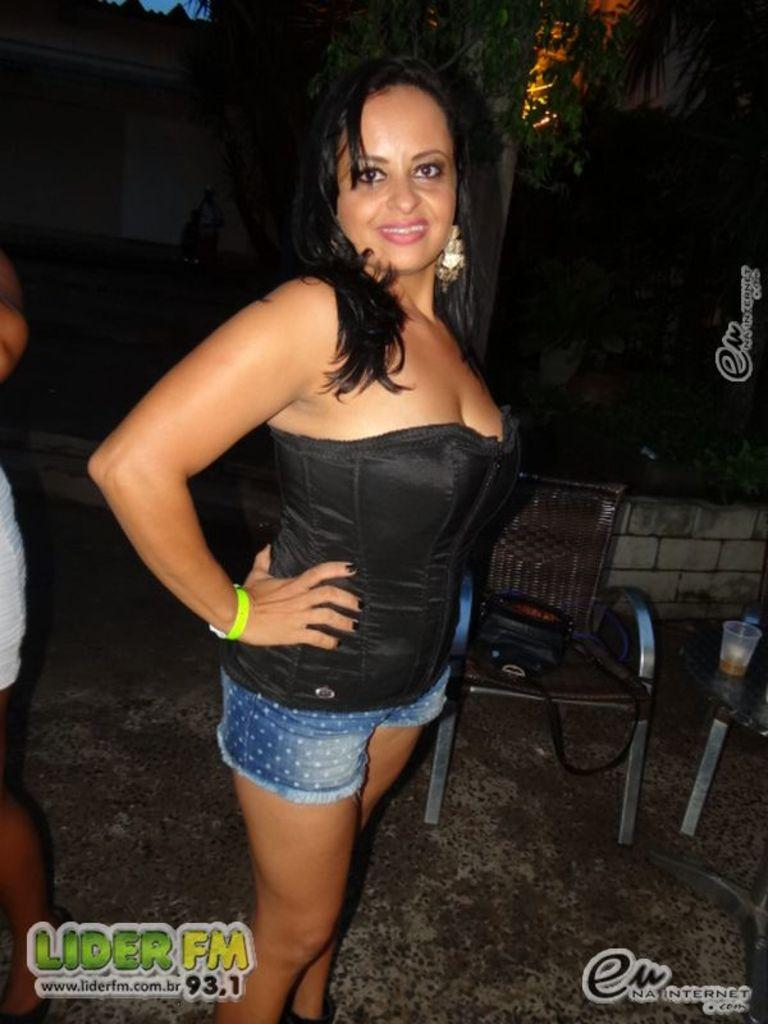What is the woman in the image doing? The woman is standing and smiling in the image. What furniture can be seen in the image? There is a chair and a table in the image. What personal item is visible in the image? There is a bag in the image. What object is on the table in the image? There is a glass on the table in the image. How many people are present in the image? There is one person, the woman, in the image. What can be seen in the background of the image? There is a tree and a wall in the background of the image. What type of celery is growing on the wall in the image? There is no celery present in the image; it only features a woman, a chair, a table, a bag, a glass, a tree, and a wall in the background. 